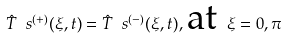Convert formula to latex. <formula><loc_0><loc_0><loc_500><loc_500>\hat { T } _ { \ } s ^ { ( + ) } ( \xi , t ) = \hat { T } _ { \ } s ^ { ( - ) } ( \xi , t ) , \, \text {at } \xi = 0 , \pi</formula> 